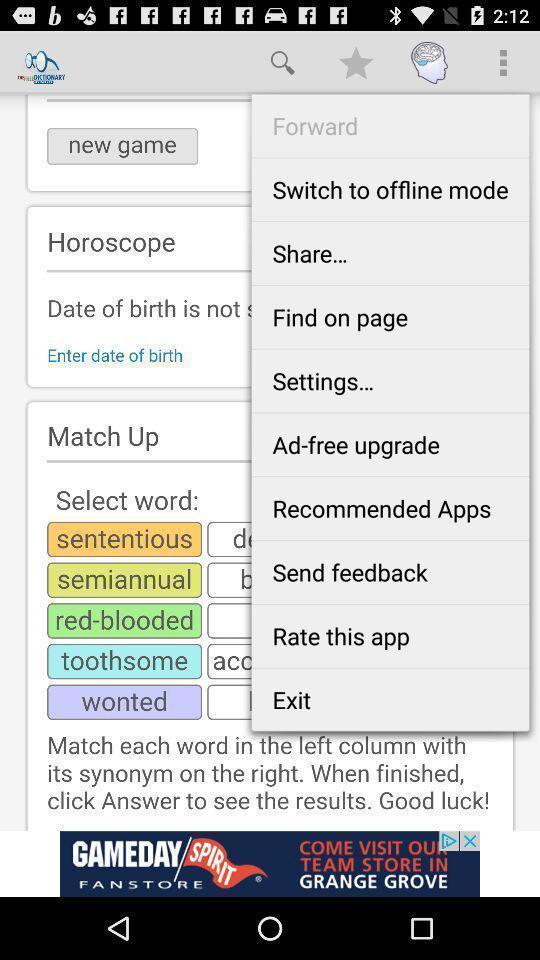Explain what's happening in this screen capture. Screen displaying list of options. 